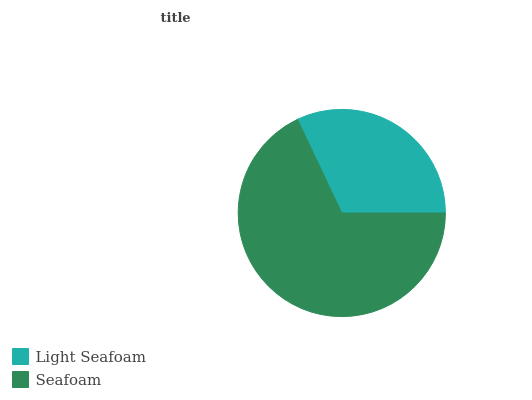Is Light Seafoam the minimum?
Answer yes or no. Yes. Is Seafoam the maximum?
Answer yes or no. Yes. Is Seafoam the minimum?
Answer yes or no. No. Is Seafoam greater than Light Seafoam?
Answer yes or no. Yes. Is Light Seafoam less than Seafoam?
Answer yes or no. Yes. Is Light Seafoam greater than Seafoam?
Answer yes or no. No. Is Seafoam less than Light Seafoam?
Answer yes or no. No. Is Seafoam the high median?
Answer yes or no. Yes. Is Light Seafoam the low median?
Answer yes or no. Yes. Is Light Seafoam the high median?
Answer yes or no. No. Is Seafoam the low median?
Answer yes or no. No. 